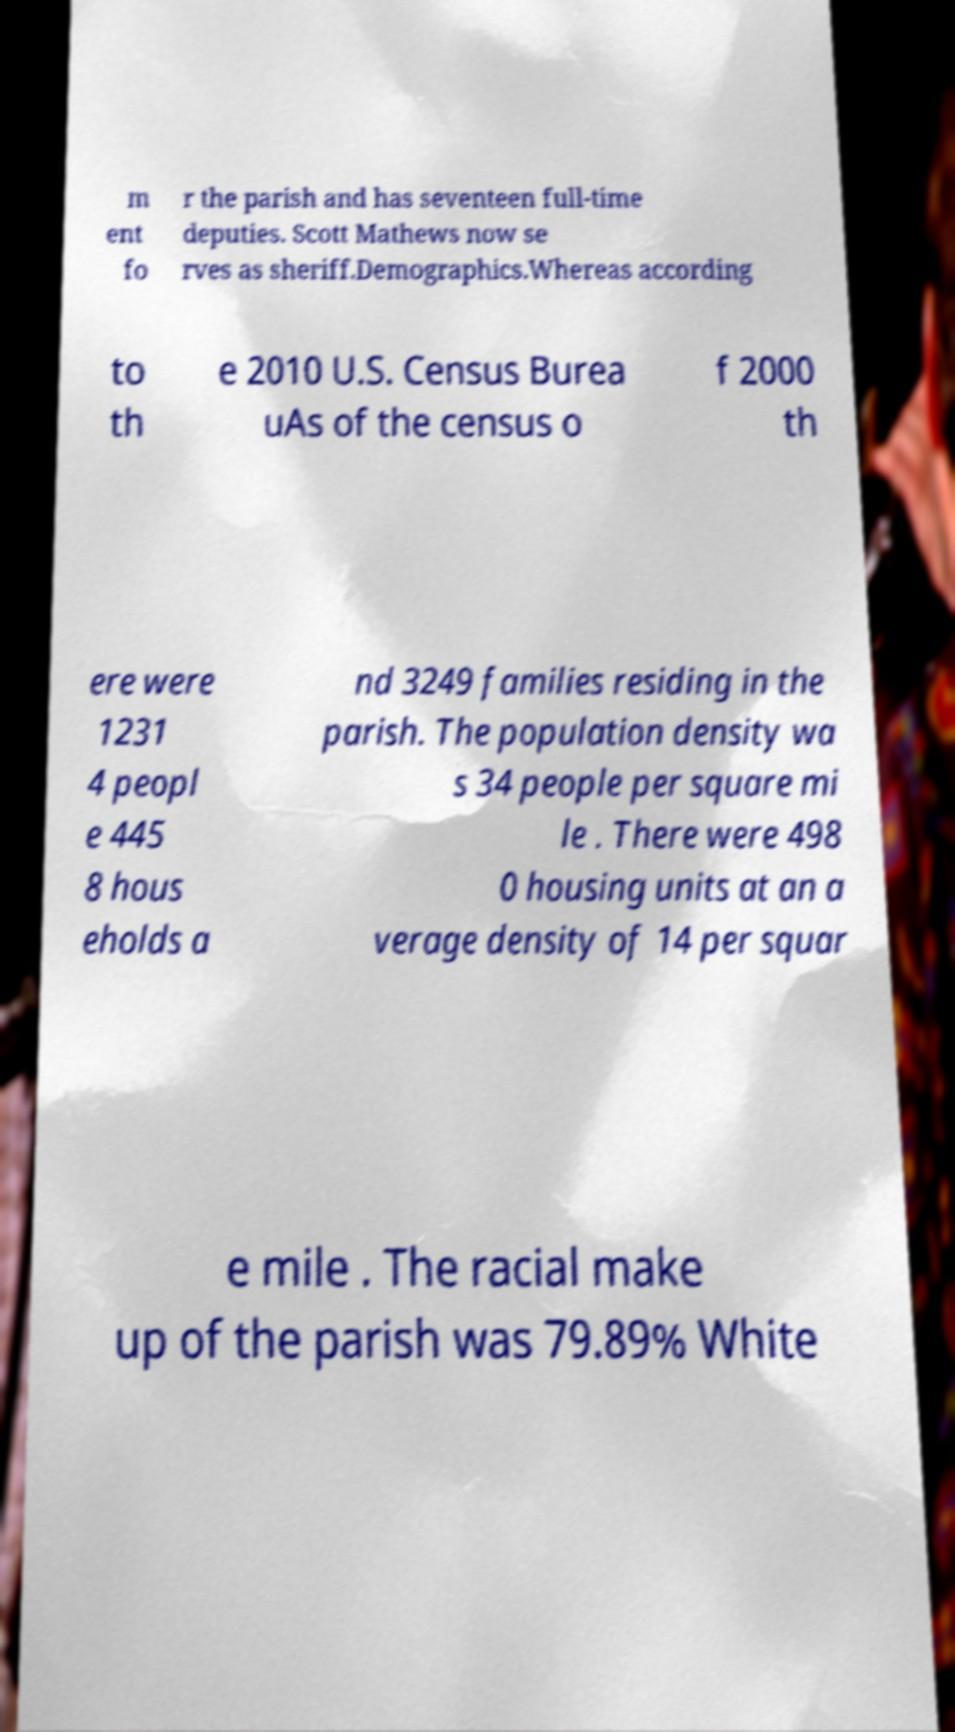Can you read and provide the text displayed in the image?This photo seems to have some interesting text. Can you extract and type it out for me? m ent fo r the parish and has seventeen full-time deputies. Scott Mathews now se rves as sheriff.Demographics.Whereas according to th e 2010 U.S. Census Burea uAs of the census o f 2000 th ere were 1231 4 peopl e 445 8 hous eholds a nd 3249 families residing in the parish. The population density wa s 34 people per square mi le . There were 498 0 housing units at an a verage density of 14 per squar e mile . The racial make up of the parish was 79.89% White 